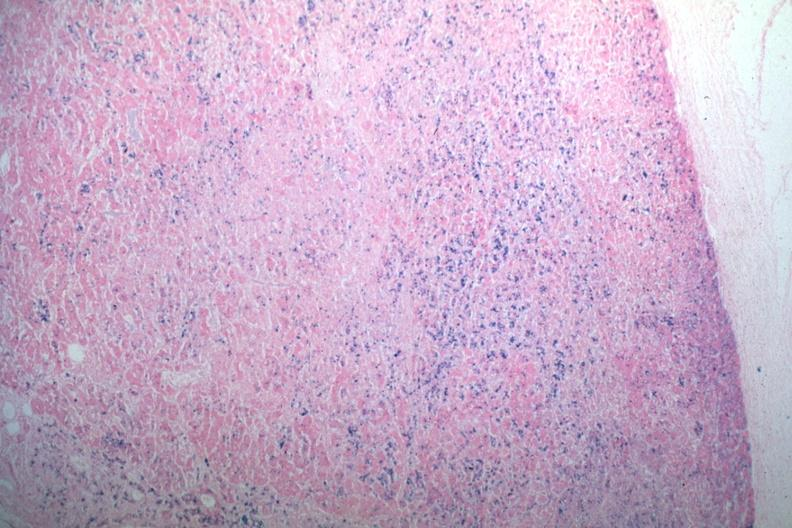s pituitary present?
Answer the question using a single word or phrase. Yes 